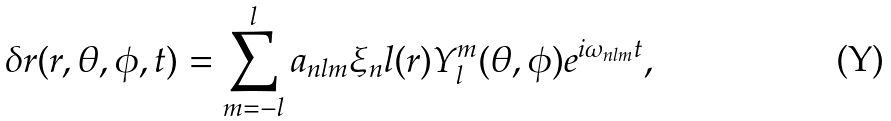Convert formula to latex. <formula><loc_0><loc_0><loc_500><loc_500>\delta r ( r , \theta , \phi , t ) = \sum _ { m = - l } ^ { l } { a _ { n l m } \xi _ { n } l ( r ) Y _ { l } ^ { m } ( \theta , \phi ) e ^ { i \omega _ { n l m } t } } ,</formula> 